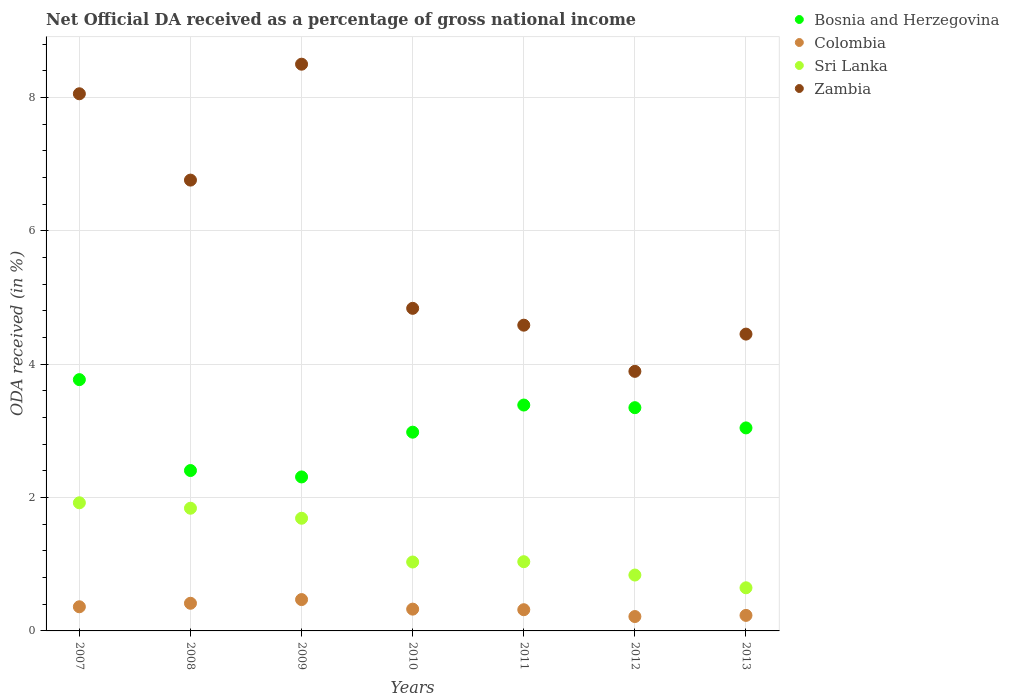How many different coloured dotlines are there?
Give a very brief answer. 4. What is the net official DA received in Sri Lanka in 2012?
Make the answer very short. 0.84. Across all years, what is the maximum net official DA received in Bosnia and Herzegovina?
Give a very brief answer. 3.77. Across all years, what is the minimum net official DA received in Sri Lanka?
Keep it short and to the point. 0.65. In which year was the net official DA received in Colombia maximum?
Offer a terse response. 2009. What is the total net official DA received in Zambia in the graph?
Make the answer very short. 41.08. What is the difference between the net official DA received in Colombia in 2010 and that in 2011?
Your answer should be compact. 0.01. What is the difference between the net official DA received in Sri Lanka in 2013 and the net official DA received in Colombia in 2010?
Provide a succinct answer. 0.32. What is the average net official DA received in Colombia per year?
Offer a very short reply. 0.33. In the year 2011, what is the difference between the net official DA received in Bosnia and Herzegovina and net official DA received in Zambia?
Your answer should be very brief. -1.2. What is the ratio of the net official DA received in Zambia in 2008 to that in 2010?
Provide a succinct answer. 1.4. Is the difference between the net official DA received in Bosnia and Herzegovina in 2007 and 2013 greater than the difference between the net official DA received in Zambia in 2007 and 2013?
Your answer should be compact. No. What is the difference between the highest and the second highest net official DA received in Colombia?
Your response must be concise. 0.06. What is the difference between the highest and the lowest net official DA received in Zambia?
Keep it short and to the point. 4.61. In how many years, is the net official DA received in Zambia greater than the average net official DA received in Zambia taken over all years?
Offer a very short reply. 3. Is the sum of the net official DA received in Zambia in 2007 and 2012 greater than the maximum net official DA received in Colombia across all years?
Your response must be concise. Yes. Is it the case that in every year, the sum of the net official DA received in Sri Lanka and net official DA received in Zambia  is greater than the net official DA received in Colombia?
Make the answer very short. Yes. Does the net official DA received in Colombia monotonically increase over the years?
Offer a terse response. No. Is the net official DA received in Zambia strictly less than the net official DA received in Sri Lanka over the years?
Keep it short and to the point. No. How many dotlines are there?
Offer a very short reply. 4. How many legend labels are there?
Ensure brevity in your answer.  4. How are the legend labels stacked?
Your response must be concise. Vertical. What is the title of the graph?
Ensure brevity in your answer.  Net Official DA received as a percentage of gross national income. What is the label or title of the X-axis?
Offer a terse response. Years. What is the label or title of the Y-axis?
Keep it short and to the point. ODA received (in %). What is the ODA received (in %) of Bosnia and Herzegovina in 2007?
Give a very brief answer. 3.77. What is the ODA received (in %) in Colombia in 2007?
Your answer should be compact. 0.36. What is the ODA received (in %) in Sri Lanka in 2007?
Provide a short and direct response. 1.92. What is the ODA received (in %) of Zambia in 2007?
Make the answer very short. 8.05. What is the ODA received (in %) in Bosnia and Herzegovina in 2008?
Provide a short and direct response. 2.41. What is the ODA received (in %) in Colombia in 2008?
Your answer should be very brief. 0.41. What is the ODA received (in %) in Sri Lanka in 2008?
Offer a terse response. 1.84. What is the ODA received (in %) of Zambia in 2008?
Give a very brief answer. 6.76. What is the ODA received (in %) of Bosnia and Herzegovina in 2009?
Keep it short and to the point. 2.31. What is the ODA received (in %) in Colombia in 2009?
Make the answer very short. 0.47. What is the ODA received (in %) in Sri Lanka in 2009?
Provide a succinct answer. 1.69. What is the ODA received (in %) of Zambia in 2009?
Offer a very short reply. 8.5. What is the ODA received (in %) of Bosnia and Herzegovina in 2010?
Ensure brevity in your answer.  2.98. What is the ODA received (in %) in Colombia in 2010?
Provide a short and direct response. 0.33. What is the ODA received (in %) of Sri Lanka in 2010?
Your answer should be compact. 1.03. What is the ODA received (in %) of Zambia in 2010?
Offer a very short reply. 4.84. What is the ODA received (in %) in Bosnia and Herzegovina in 2011?
Offer a terse response. 3.39. What is the ODA received (in %) of Colombia in 2011?
Ensure brevity in your answer.  0.32. What is the ODA received (in %) of Sri Lanka in 2011?
Your answer should be compact. 1.04. What is the ODA received (in %) of Zambia in 2011?
Your response must be concise. 4.58. What is the ODA received (in %) in Bosnia and Herzegovina in 2012?
Make the answer very short. 3.35. What is the ODA received (in %) of Colombia in 2012?
Your answer should be compact. 0.22. What is the ODA received (in %) of Sri Lanka in 2012?
Your response must be concise. 0.84. What is the ODA received (in %) of Zambia in 2012?
Ensure brevity in your answer.  3.89. What is the ODA received (in %) in Bosnia and Herzegovina in 2013?
Keep it short and to the point. 3.04. What is the ODA received (in %) of Colombia in 2013?
Your answer should be compact. 0.23. What is the ODA received (in %) in Sri Lanka in 2013?
Your answer should be compact. 0.65. What is the ODA received (in %) in Zambia in 2013?
Your answer should be very brief. 4.45. Across all years, what is the maximum ODA received (in %) of Bosnia and Herzegovina?
Your answer should be compact. 3.77. Across all years, what is the maximum ODA received (in %) of Colombia?
Ensure brevity in your answer.  0.47. Across all years, what is the maximum ODA received (in %) in Sri Lanka?
Your answer should be very brief. 1.92. Across all years, what is the maximum ODA received (in %) in Zambia?
Provide a short and direct response. 8.5. Across all years, what is the minimum ODA received (in %) in Bosnia and Herzegovina?
Keep it short and to the point. 2.31. Across all years, what is the minimum ODA received (in %) of Colombia?
Offer a very short reply. 0.22. Across all years, what is the minimum ODA received (in %) in Sri Lanka?
Your answer should be compact. 0.65. Across all years, what is the minimum ODA received (in %) of Zambia?
Provide a succinct answer. 3.89. What is the total ODA received (in %) of Bosnia and Herzegovina in the graph?
Offer a very short reply. 21.24. What is the total ODA received (in %) of Colombia in the graph?
Your answer should be very brief. 2.34. What is the total ODA received (in %) in Sri Lanka in the graph?
Your answer should be very brief. 9.01. What is the total ODA received (in %) in Zambia in the graph?
Your answer should be very brief. 41.08. What is the difference between the ODA received (in %) of Bosnia and Herzegovina in 2007 and that in 2008?
Offer a very short reply. 1.36. What is the difference between the ODA received (in %) of Colombia in 2007 and that in 2008?
Provide a succinct answer. -0.05. What is the difference between the ODA received (in %) in Sri Lanka in 2007 and that in 2008?
Offer a very short reply. 0.08. What is the difference between the ODA received (in %) in Zambia in 2007 and that in 2008?
Your response must be concise. 1.29. What is the difference between the ODA received (in %) in Bosnia and Herzegovina in 2007 and that in 2009?
Provide a short and direct response. 1.46. What is the difference between the ODA received (in %) of Colombia in 2007 and that in 2009?
Provide a short and direct response. -0.11. What is the difference between the ODA received (in %) in Sri Lanka in 2007 and that in 2009?
Offer a terse response. 0.23. What is the difference between the ODA received (in %) of Zambia in 2007 and that in 2009?
Your answer should be compact. -0.44. What is the difference between the ODA received (in %) in Bosnia and Herzegovina in 2007 and that in 2010?
Provide a succinct answer. 0.79. What is the difference between the ODA received (in %) in Colombia in 2007 and that in 2010?
Offer a very short reply. 0.04. What is the difference between the ODA received (in %) in Sri Lanka in 2007 and that in 2010?
Make the answer very short. 0.89. What is the difference between the ODA received (in %) in Zambia in 2007 and that in 2010?
Your answer should be compact. 3.22. What is the difference between the ODA received (in %) in Bosnia and Herzegovina in 2007 and that in 2011?
Make the answer very short. 0.38. What is the difference between the ODA received (in %) in Colombia in 2007 and that in 2011?
Provide a short and direct response. 0.04. What is the difference between the ODA received (in %) in Sri Lanka in 2007 and that in 2011?
Ensure brevity in your answer.  0.88. What is the difference between the ODA received (in %) in Zambia in 2007 and that in 2011?
Offer a very short reply. 3.47. What is the difference between the ODA received (in %) of Bosnia and Herzegovina in 2007 and that in 2012?
Provide a succinct answer. 0.42. What is the difference between the ODA received (in %) in Colombia in 2007 and that in 2012?
Offer a terse response. 0.15. What is the difference between the ODA received (in %) of Sri Lanka in 2007 and that in 2012?
Your answer should be very brief. 1.08. What is the difference between the ODA received (in %) in Zambia in 2007 and that in 2012?
Your answer should be compact. 4.16. What is the difference between the ODA received (in %) of Bosnia and Herzegovina in 2007 and that in 2013?
Ensure brevity in your answer.  0.72. What is the difference between the ODA received (in %) in Colombia in 2007 and that in 2013?
Provide a short and direct response. 0.13. What is the difference between the ODA received (in %) of Sri Lanka in 2007 and that in 2013?
Make the answer very short. 1.27. What is the difference between the ODA received (in %) in Zambia in 2007 and that in 2013?
Provide a succinct answer. 3.6. What is the difference between the ODA received (in %) of Bosnia and Herzegovina in 2008 and that in 2009?
Offer a very short reply. 0.1. What is the difference between the ODA received (in %) of Colombia in 2008 and that in 2009?
Give a very brief answer. -0.06. What is the difference between the ODA received (in %) of Sri Lanka in 2008 and that in 2009?
Offer a very short reply. 0.15. What is the difference between the ODA received (in %) of Zambia in 2008 and that in 2009?
Make the answer very short. -1.74. What is the difference between the ODA received (in %) of Bosnia and Herzegovina in 2008 and that in 2010?
Make the answer very short. -0.58. What is the difference between the ODA received (in %) of Colombia in 2008 and that in 2010?
Your answer should be very brief. 0.09. What is the difference between the ODA received (in %) in Sri Lanka in 2008 and that in 2010?
Offer a very short reply. 0.81. What is the difference between the ODA received (in %) of Zambia in 2008 and that in 2010?
Keep it short and to the point. 1.92. What is the difference between the ODA received (in %) of Bosnia and Herzegovina in 2008 and that in 2011?
Provide a short and direct response. -0.98. What is the difference between the ODA received (in %) in Colombia in 2008 and that in 2011?
Provide a short and direct response. 0.1. What is the difference between the ODA received (in %) in Sri Lanka in 2008 and that in 2011?
Keep it short and to the point. 0.8. What is the difference between the ODA received (in %) of Zambia in 2008 and that in 2011?
Your response must be concise. 2.18. What is the difference between the ODA received (in %) in Bosnia and Herzegovina in 2008 and that in 2012?
Provide a succinct answer. -0.94. What is the difference between the ODA received (in %) of Colombia in 2008 and that in 2012?
Give a very brief answer. 0.2. What is the difference between the ODA received (in %) of Sri Lanka in 2008 and that in 2012?
Keep it short and to the point. 1. What is the difference between the ODA received (in %) of Zambia in 2008 and that in 2012?
Keep it short and to the point. 2.87. What is the difference between the ODA received (in %) of Bosnia and Herzegovina in 2008 and that in 2013?
Your answer should be very brief. -0.64. What is the difference between the ODA received (in %) of Colombia in 2008 and that in 2013?
Offer a very short reply. 0.18. What is the difference between the ODA received (in %) of Sri Lanka in 2008 and that in 2013?
Make the answer very short. 1.19. What is the difference between the ODA received (in %) of Zambia in 2008 and that in 2013?
Offer a very short reply. 2.31. What is the difference between the ODA received (in %) in Bosnia and Herzegovina in 2009 and that in 2010?
Ensure brevity in your answer.  -0.67. What is the difference between the ODA received (in %) of Colombia in 2009 and that in 2010?
Your answer should be compact. 0.14. What is the difference between the ODA received (in %) of Sri Lanka in 2009 and that in 2010?
Offer a terse response. 0.66. What is the difference between the ODA received (in %) in Zambia in 2009 and that in 2010?
Your answer should be compact. 3.66. What is the difference between the ODA received (in %) of Bosnia and Herzegovina in 2009 and that in 2011?
Offer a terse response. -1.08. What is the difference between the ODA received (in %) of Colombia in 2009 and that in 2011?
Your answer should be very brief. 0.15. What is the difference between the ODA received (in %) in Sri Lanka in 2009 and that in 2011?
Offer a terse response. 0.65. What is the difference between the ODA received (in %) of Zambia in 2009 and that in 2011?
Offer a terse response. 3.91. What is the difference between the ODA received (in %) in Bosnia and Herzegovina in 2009 and that in 2012?
Ensure brevity in your answer.  -1.04. What is the difference between the ODA received (in %) of Colombia in 2009 and that in 2012?
Your answer should be compact. 0.25. What is the difference between the ODA received (in %) of Sri Lanka in 2009 and that in 2012?
Ensure brevity in your answer.  0.85. What is the difference between the ODA received (in %) in Zambia in 2009 and that in 2012?
Ensure brevity in your answer.  4.61. What is the difference between the ODA received (in %) in Bosnia and Herzegovina in 2009 and that in 2013?
Provide a short and direct response. -0.74. What is the difference between the ODA received (in %) in Colombia in 2009 and that in 2013?
Offer a terse response. 0.24. What is the difference between the ODA received (in %) of Sri Lanka in 2009 and that in 2013?
Ensure brevity in your answer.  1.04. What is the difference between the ODA received (in %) of Zambia in 2009 and that in 2013?
Your answer should be compact. 4.05. What is the difference between the ODA received (in %) of Bosnia and Herzegovina in 2010 and that in 2011?
Provide a succinct answer. -0.41. What is the difference between the ODA received (in %) of Colombia in 2010 and that in 2011?
Provide a short and direct response. 0.01. What is the difference between the ODA received (in %) in Sri Lanka in 2010 and that in 2011?
Your answer should be compact. -0. What is the difference between the ODA received (in %) of Zambia in 2010 and that in 2011?
Ensure brevity in your answer.  0.25. What is the difference between the ODA received (in %) of Bosnia and Herzegovina in 2010 and that in 2012?
Your response must be concise. -0.37. What is the difference between the ODA received (in %) in Colombia in 2010 and that in 2012?
Your response must be concise. 0.11. What is the difference between the ODA received (in %) in Sri Lanka in 2010 and that in 2012?
Ensure brevity in your answer.  0.2. What is the difference between the ODA received (in %) in Zambia in 2010 and that in 2012?
Your answer should be compact. 0.94. What is the difference between the ODA received (in %) in Bosnia and Herzegovina in 2010 and that in 2013?
Ensure brevity in your answer.  -0.06. What is the difference between the ODA received (in %) in Colombia in 2010 and that in 2013?
Ensure brevity in your answer.  0.09. What is the difference between the ODA received (in %) of Sri Lanka in 2010 and that in 2013?
Ensure brevity in your answer.  0.39. What is the difference between the ODA received (in %) of Zambia in 2010 and that in 2013?
Keep it short and to the point. 0.39. What is the difference between the ODA received (in %) of Bosnia and Herzegovina in 2011 and that in 2012?
Make the answer very short. 0.04. What is the difference between the ODA received (in %) in Colombia in 2011 and that in 2012?
Provide a succinct answer. 0.1. What is the difference between the ODA received (in %) of Sri Lanka in 2011 and that in 2012?
Make the answer very short. 0.2. What is the difference between the ODA received (in %) in Zambia in 2011 and that in 2012?
Your answer should be compact. 0.69. What is the difference between the ODA received (in %) of Bosnia and Herzegovina in 2011 and that in 2013?
Offer a terse response. 0.34. What is the difference between the ODA received (in %) of Colombia in 2011 and that in 2013?
Offer a very short reply. 0.09. What is the difference between the ODA received (in %) of Sri Lanka in 2011 and that in 2013?
Offer a very short reply. 0.39. What is the difference between the ODA received (in %) in Zambia in 2011 and that in 2013?
Keep it short and to the point. 0.13. What is the difference between the ODA received (in %) of Bosnia and Herzegovina in 2012 and that in 2013?
Keep it short and to the point. 0.3. What is the difference between the ODA received (in %) of Colombia in 2012 and that in 2013?
Your answer should be compact. -0.02. What is the difference between the ODA received (in %) in Sri Lanka in 2012 and that in 2013?
Make the answer very short. 0.19. What is the difference between the ODA received (in %) of Zambia in 2012 and that in 2013?
Your response must be concise. -0.56. What is the difference between the ODA received (in %) of Bosnia and Herzegovina in 2007 and the ODA received (in %) of Colombia in 2008?
Your answer should be compact. 3.35. What is the difference between the ODA received (in %) in Bosnia and Herzegovina in 2007 and the ODA received (in %) in Sri Lanka in 2008?
Provide a succinct answer. 1.93. What is the difference between the ODA received (in %) of Bosnia and Herzegovina in 2007 and the ODA received (in %) of Zambia in 2008?
Provide a short and direct response. -2.99. What is the difference between the ODA received (in %) in Colombia in 2007 and the ODA received (in %) in Sri Lanka in 2008?
Your answer should be very brief. -1.48. What is the difference between the ODA received (in %) in Colombia in 2007 and the ODA received (in %) in Zambia in 2008?
Your answer should be very brief. -6.4. What is the difference between the ODA received (in %) of Sri Lanka in 2007 and the ODA received (in %) of Zambia in 2008?
Make the answer very short. -4.84. What is the difference between the ODA received (in %) of Bosnia and Herzegovina in 2007 and the ODA received (in %) of Colombia in 2009?
Your response must be concise. 3.3. What is the difference between the ODA received (in %) in Bosnia and Herzegovina in 2007 and the ODA received (in %) in Sri Lanka in 2009?
Keep it short and to the point. 2.08. What is the difference between the ODA received (in %) of Bosnia and Herzegovina in 2007 and the ODA received (in %) of Zambia in 2009?
Make the answer very short. -4.73. What is the difference between the ODA received (in %) of Colombia in 2007 and the ODA received (in %) of Sri Lanka in 2009?
Provide a succinct answer. -1.33. What is the difference between the ODA received (in %) in Colombia in 2007 and the ODA received (in %) in Zambia in 2009?
Offer a very short reply. -8.14. What is the difference between the ODA received (in %) of Sri Lanka in 2007 and the ODA received (in %) of Zambia in 2009?
Provide a short and direct response. -6.58. What is the difference between the ODA received (in %) of Bosnia and Herzegovina in 2007 and the ODA received (in %) of Colombia in 2010?
Offer a terse response. 3.44. What is the difference between the ODA received (in %) in Bosnia and Herzegovina in 2007 and the ODA received (in %) in Sri Lanka in 2010?
Give a very brief answer. 2.73. What is the difference between the ODA received (in %) in Bosnia and Herzegovina in 2007 and the ODA received (in %) in Zambia in 2010?
Provide a succinct answer. -1.07. What is the difference between the ODA received (in %) in Colombia in 2007 and the ODA received (in %) in Sri Lanka in 2010?
Give a very brief answer. -0.67. What is the difference between the ODA received (in %) in Colombia in 2007 and the ODA received (in %) in Zambia in 2010?
Ensure brevity in your answer.  -4.48. What is the difference between the ODA received (in %) of Sri Lanka in 2007 and the ODA received (in %) of Zambia in 2010?
Keep it short and to the point. -2.92. What is the difference between the ODA received (in %) of Bosnia and Herzegovina in 2007 and the ODA received (in %) of Colombia in 2011?
Make the answer very short. 3.45. What is the difference between the ODA received (in %) in Bosnia and Herzegovina in 2007 and the ODA received (in %) in Sri Lanka in 2011?
Provide a succinct answer. 2.73. What is the difference between the ODA received (in %) of Bosnia and Herzegovina in 2007 and the ODA received (in %) of Zambia in 2011?
Ensure brevity in your answer.  -0.82. What is the difference between the ODA received (in %) of Colombia in 2007 and the ODA received (in %) of Sri Lanka in 2011?
Provide a short and direct response. -0.68. What is the difference between the ODA received (in %) in Colombia in 2007 and the ODA received (in %) in Zambia in 2011?
Your answer should be compact. -4.22. What is the difference between the ODA received (in %) in Sri Lanka in 2007 and the ODA received (in %) in Zambia in 2011?
Keep it short and to the point. -2.66. What is the difference between the ODA received (in %) of Bosnia and Herzegovina in 2007 and the ODA received (in %) of Colombia in 2012?
Keep it short and to the point. 3.55. What is the difference between the ODA received (in %) in Bosnia and Herzegovina in 2007 and the ODA received (in %) in Sri Lanka in 2012?
Your answer should be compact. 2.93. What is the difference between the ODA received (in %) in Bosnia and Herzegovina in 2007 and the ODA received (in %) in Zambia in 2012?
Provide a succinct answer. -0.12. What is the difference between the ODA received (in %) of Colombia in 2007 and the ODA received (in %) of Sri Lanka in 2012?
Provide a succinct answer. -0.48. What is the difference between the ODA received (in %) of Colombia in 2007 and the ODA received (in %) of Zambia in 2012?
Give a very brief answer. -3.53. What is the difference between the ODA received (in %) of Sri Lanka in 2007 and the ODA received (in %) of Zambia in 2012?
Your answer should be very brief. -1.97. What is the difference between the ODA received (in %) in Bosnia and Herzegovina in 2007 and the ODA received (in %) in Colombia in 2013?
Your answer should be very brief. 3.54. What is the difference between the ODA received (in %) in Bosnia and Herzegovina in 2007 and the ODA received (in %) in Sri Lanka in 2013?
Provide a succinct answer. 3.12. What is the difference between the ODA received (in %) in Bosnia and Herzegovina in 2007 and the ODA received (in %) in Zambia in 2013?
Make the answer very short. -0.68. What is the difference between the ODA received (in %) in Colombia in 2007 and the ODA received (in %) in Sri Lanka in 2013?
Offer a very short reply. -0.28. What is the difference between the ODA received (in %) of Colombia in 2007 and the ODA received (in %) of Zambia in 2013?
Keep it short and to the point. -4.09. What is the difference between the ODA received (in %) of Sri Lanka in 2007 and the ODA received (in %) of Zambia in 2013?
Make the answer very short. -2.53. What is the difference between the ODA received (in %) in Bosnia and Herzegovina in 2008 and the ODA received (in %) in Colombia in 2009?
Make the answer very short. 1.94. What is the difference between the ODA received (in %) in Bosnia and Herzegovina in 2008 and the ODA received (in %) in Sri Lanka in 2009?
Keep it short and to the point. 0.72. What is the difference between the ODA received (in %) of Bosnia and Herzegovina in 2008 and the ODA received (in %) of Zambia in 2009?
Your answer should be compact. -6.09. What is the difference between the ODA received (in %) in Colombia in 2008 and the ODA received (in %) in Sri Lanka in 2009?
Your answer should be compact. -1.27. What is the difference between the ODA received (in %) in Colombia in 2008 and the ODA received (in %) in Zambia in 2009?
Ensure brevity in your answer.  -8.08. What is the difference between the ODA received (in %) of Sri Lanka in 2008 and the ODA received (in %) of Zambia in 2009?
Your answer should be very brief. -6.66. What is the difference between the ODA received (in %) in Bosnia and Herzegovina in 2008 and the ODA received (in %) in Colombia in 2010?
Make the answer very short. 2.08. What is the difference between the ODA received (in %) of Bosnia and Herzegovina in 2008 and the ODA received (in %) of Sri Lanka in 2010?
Your answer should be very brief. 1.37. What is the difference between the ODA received (in %) in Bosnia and Herzegovina in 2008 and the ODA received (in %) in Zambia in 2010?
Provide a succinct answer. -2.43. What is the difference between the ODA received (in %) of Colombia in 2008 and the ODA received (in %) of Sri Lanka in 2010?
Make the answer very short. -0.62. What is the difference between the ODA received (in %) of Colombia in 2008 and the ODA received (in %) of Zambia in 2010?
Offer a very short reply. -4.42. What is the difference between the ODA received (in %) in Sri Lanka in 2008 and the ODA received (in %) in Zambia in 2010?
Your answer should be very brief. -3. What is the difference between the ODA received (in %) in Bosnia and Herzegovina in 2008 and the ODA received (in %) in Colombia in 2011?
Make the answer very short. 2.09. What is the difference between the ODA received (in %) in Bosnia and Herzegovina in 2008 and the ODA received (in %) in Sri Lanka in 2011?
Ensure brevity in your answer.  1.37. What is the difference between the ODA received (in %) of Bosnia and Herzegovina in 2008 and the ODA received (in %) of Zambia in 2011?
Your answer should be very brief. -2.18. What is the difference between the ODA received (in %) in Colombia in 2008 and the ODA received (in %) in Sri Lanka in 2011?
Give a very brief answer. -0.62. What is the difference between the ODA received (in %) of Colombia in 2008 and the ODA received (in %) of Zambia in 2011?
Offer a very short reply. -4.17. What is the difference between the ODA received (in %) of Sri Lanka in 2008 and the ODA received (in %) of Zambia in 2011?
Provide a short and direct response. -2.74. What is the difference between the ODA received (in %) of Bosnia and Herzegovina in 2008 and the ODA received (in %) of Colombia in 2012?
Your response must be concise. 2.19. What is the difference between the ODA received (in %) in Bosnia and Herzegovina in 2008 and the ODA received (in %) in Sri Lanka in 2012?
Your answer should be compact. 1.57. What is the difference between the ODA received (in %) in Bosnia and Herzegovina in 2008 and the ODA received (in %) in Zambia in 2012?
Offer a very short reply. -1.49. What is the difference between the ODA received (in %) of Colombia in 2008 and the ODA received (in %) of Sri Lanka in 2012?
Your answer should be compact. -0.42. What is the difference between the ODA received (in %) of Colombia in 2008 and the ODA received (in %) of Zambia in 2012?
Provide a succinct answer. -3.48. What is the difference between the ODA received (in %) of Sri Lanka in 2008 and the ODA received (in %) of Zambia in 2012?
Your answer should be compact. -2.05. What is the difference between the ODA received (in %) in Bosnia and Herzegovina in 2008 and the ODA received (in %) in Colombia in 2013?
Provide a short and direct response. 2.17. What is the difference between the ODA received (in %) of Bosnia and Herzegovina in 2008 and the ODA received (in %) of Sri Lanka in 2013?
Your response must be concise. 1.76. What is the difference between the ODA received (in %) in Bosnia and Herzegovina in 2008 and the ODA received (in %) in Zambia in 2013?
Give a very brief answer. -2.05. What is the difference between the ODA received (in %) in Colombia in 2008 and the ODA received (in %) in Sri Lanka in 2013?
Offer a terse response. -0.23. What is the difference between the ODA received (in %) in Colombia in 2008 and the ODA received (in %) in Zambia in 2013?
Offer a terse response. -4.04. What is the difference between the ODA received (in %) in Sri Lanka in 2008 and the ODA received (in %) in Zambia in 2013?
Make the answer very short. -2.61. What is the difference between the ODA received (in %) in Bosnia and Herzegovina in 2009 and the ODA received (in %) in Colombia in 2010?
Your response must be concise. 1.98. What is the difference between the ODA received (in %) of Bosnia and Herzegovina in 2009 and the ODA received (in %) of Sri Lanka in 2010?
Make the answer very short. 1.28. What is the difference between the ODA received (in %) in Bosnia and Herzegovina in 2009 and the ODA received (in %) in Zambia in 2010?
Your answer should be very brief. -2.53. What is the difference between the ODA received (in %) of Colombia in 2009 and the ODA received (in %) of Sri Lanka in 2010?
Make the answer very short. -0.56. What is the difference between the ODA received (in %) in Colombia in 2009 and the ODA received (in %) in Zambia in 2010?
Ensure brevity in your answer.  -4.37. What is the difference between the ODA received (in %) in Sri Lanka in 2009 and the ODA received (in %) in Zambia in 2010?
Ensure brevity in your answer.  -3.15. What is the difference between the ODA received (in %) in Bosnia and Herzegovina in 2009 and the ODA received (in %) in Colombia in 2011?
Offer a terse response. 1.99. What is the difference between the ODA received (in %) of Bosnia and Herzegovina in 2009 and the ODA received (in %) of Sri Lanka in 2011?
Your response must be concise. 1.27. What is the difference between the ODA received (in %) of Bosnia and Herzegovina in 2009 and the ODA received (in %) of Zambia in 2011?
Ensure brevity in your answer.  -2.28. What is the difference between the ODA received (in %) of Colombia in 2009 and the ODA received (in %) of Sri Lanka in 2011?
Make the answer very short. -0.57. What is the difference between the ODA received (in %) of Colombia in 2009 and the ODA received (in %) of Zambia in 2011?
Make the answer very short. -4.11. What is the difference between the ODA received (in %) in Sri Lanka in 2009 and the ODA received (in %) in Zambia in 2011?
Keep it short and to the point. -2.9. What is the difference between the ODA received (in %) of Bosnia and Herzegovina in 2009 and the ODA received (in %) of Colombia in 2012?
Your answer should be compact. 2.09. What is the difference between the ODA received (in %) in Bosnia and Herzegovina in 2009 and the ODA received (in %) in Sri Lanka in 2012?
Your response must be concise. 1.47. What is the difference between the ODA received (in %) in Bosnia and Herzegovina in 2009 and the ODA received (in %) in Zambia in 2012?
Give a very brief answer. -1.58. What is the difference between the ODA received (in %) in Colombia in 2009 and the ODA received (in %) in Sri Lanka in 2012?
Your response must be concise. -0.37. What is the difference between the ODA received (in %) in Colombia in 2009 and the ODA received (in %) in Zambia in 2012?
Keep it short and to the point. -3.42. What is the difference between the ODA received (in %) in Sri Lanka in 2009 and the ODA received (in %) in Zambia in 2012?
Provide a succinct answer. -2.2. What is the difference between the ODA received (in %) of Bosnia and Herzegovina in 2009 and the ODA received (in %) of Colombia in 2013?
Make the answer very short. 2.08. What is the difference between the ODA received (in %) in Bosnia and Herzegovina in 2009 and the ODA received (in %) in Sri Lanka in 2013?
Make the answer very short. 1.66. What is the difference between the ODA received (in %) of Bosnia and Herzegovina in 2009 and the ODA received (in %) of Zambia in 2013?
Offer a terse response. -2.14. What is the difference between the ODA received (in %) in Colombia in 2009 and the ODA received (in %) in Sri Lanka in 2013?
Your answer should be compact. -0.18. What is the difference between the ODA received (in %) in Colombia in 2009 and the ODA received (in %) in Zambia in 2013?
Provide a short and direct response. -3.98. What is the difference between the ODA received (in %) of Sri Lanka in 2009 and the ODA received (in %) of Zambia in 2013?
Keep it short and to the point. -2.76. What is the difference between the ODA received (in %) in Bosnia and Herzegovina in 2010 and the ODA received (in %) in Colombia in 2011?
Your answer should be compact. 2.66. What is the difference between the ODA received (in %) in Bosnia and Herzegovina in 2010 and the ODA received (in %) in Sri Lanka in 2011?
Your answer should be very brief. 1.94. What is the difference between the ODA received (in %) of Bosnia and Herzegovina in 2010 and the ODA received (in %) of Zambia in 2011?
Provide a succinct answer. -1.6. What is the difference between the ODA received (in %) of Colombia in 2010 and the ODA received (in %) of Sri Lanka in 2011?
Your answer should be very brief. -0.71. What is the difference between the ODA received (in %) of Colombia in 2010 and the ODA received (in %) of Zambia in 2011?
Provide a short and direct response. -4.26. What is the difference between the ODA received (in %) in Sri Lanka in 2010 and the ODA received (in %) in Zambia in 2011?
Your answer should be compact. -3.55. What is the difference between the ODA received (in %) of Bosnia and Herzegovina in 2010 and the ODA received (in %) of Colombia in 2012?
Offer a very short reply. 2.76. What is the difference between the ODA received (in %) of Bosnia and Herzegovina in 2010 and the ODA received (in %) of Sri Lanka in 2012?
Provide a short and direct response. 2.14. What is the difference between the ODA received (in %) of Bosnia and Herzegovina in 2010 and the ODA received (in %) of Zambia in 2012?
Your response must be concise. -0.91. What is the difference between the ODA received (in %) of Colombia in 2010 and the ODA received (in %) of Sri Lanka in 2012?
Give a very brief answer. -0.51. What is the difference between the ODA received (in %) of Colombia in 2010 and the ODA received (in %) of Zambia in 2012?
Ensure brevity in your answer.  -3.57. What is the difference between the ODA received (in %) of Sri Lanka in 2010 and the ODA received (in %) of Zambia in 2012?
Offer a terse response. -2.86. What is the difference between the ODA received (in %) in Bosnia and Herzegovina in 2010 and the ODA received (in %) in Colombia in 2013?
Keep it short and to the point. 2.75. What is the difference between the ODA received (in %) in Bosnia and Herzegovina in 2010 and the ODA received (in %) in Sri Lanka in 2013?
Offer a terse response. 2.33. What is the difference between the ODA received (in %) in Bosnia and Herzegovina in 2010 and the ODA received (in %) in Zambia in 2013?
Provide a short and direct response. -1.47. What is the difference between the ODA received (in %) in Colombia in 2010 and the ODA received (in %) in Sri Lanka in 2013?
Your answer should be compact. -0.32. What is the difference between the ODA received (in %) of Colombia in 2010 and the ODA received (in %) of Zambia in 2013?
Ensure brevity in your answer.  -4.12. What is the difference between the ODA received (in %) in Sri Lanka in 2010 and the ODA received (in %) in Zambia in 2013?
Offer a terse response. -3.42. What is the difference between the ODA received (in %) of Bosnia and Herzegovina in 2011 and the ODA received (in %) of Colombia in 2012?
Provide a succinct answer. 3.17. What is the difference between the ODA received (in %) in Bosnia and Herzegovina in 2011 and the ODA received (in %) in Sri Lanka in 2012?
Provide a succinct answer. 2.55. What is the difference between the ODA received (in %) in Bosnia and Herzegovina in 2011 and the ODA received (in %) in Zambia in 2012?
Provide a succinct answer. -0.51. What is the difference between the ODA received (in %) of Colombia in 2011 and the ODA received (in %) of Sri Lanka in 2012?
Give a very brief answer. -0.52. What is the difference between the ODA received (in %) of Colombia in 2011 and the ODA received (in %) of Zambia in 2012?
Your answer should be compact. -3.57. What is the difference between the ODA received (in %) in Sri Lanka in 2011 and the ODA received (in %) in Zambia in 2012?
Give a very brief answer. -2.85. What is the difference between the ODA received (in %) of Bosnia and Herzegovina in 2011 and the ODA received (in %) of Colombia in 2013?
Make the answer very short. 3.15. What is the difference between the ODA received (in %) of Bosnia and Herzegovina in 2011 and the ODA received (in %) of Sri Lanka in 2013?
Keep it short and to the point. 2.74. What is the difference between the ODA received (in %) of Bosnia and Herzegovina in 2011 and the ODA received (in %) of Zambia in 2013?
Provide a succinct answer. -1.06. What is the difference between the ODA received (in %) in Colombia in 2011 and the ODA received (in %) in Sri Lanka in 2013?
Your answer should be very brief. -0.33. What is the difference between the ODA received (in %) of Colombia in 2011 and the ODA received (in %) of Zambia in 2013?
Offer a terse response. -4.13. What is the difference between the ODA received (in %) of Sri Lanka in 2011 and the ODA received (in %) of Zambia in 2013?
Give a very brief answer. -3.41. What is the difference between the ODA received (in %) in Bosnia and Herzegovina in 2012 and the ODA received (in %) in Colombia in 2013?
Keep it short and to the point. 3.11. What is the difference between the ODA received (in %) in Bosnia and Herzegovina in 2012 and the ODA received (in %) in Sri Lanka in 2013?
Give a very brief answer. 2.7. What is the difference between the ODA received (in %) in Bosnia and Herzegovina in 2012 and the ODA received (in %) in Zambia in 2013?
Your answer should be very brief. -1.1. What is the difference between the ODA received (in %) in Colombia in 2012 and the ODA received (in %) in Sri Lanka in 2013?
Provide a short and direct response. -0.43. What is the difference between the ODA received (in %) of Colombia in 2012 and the ODA received (in %) of Zambia in 2013?
Provide a short and direct response. -4.24. What is the difference between the ODA received (in %) of Sri Lanka in 2012 and the ODA received (in %) of Zambia in 2013?
Your answer should be compact. -3.61. What is the average ODA received (in %) of Bosnia and Herzegovina per year?
Your answer should be very brief. 3.03. What is the average ODA received (in %) in Colombia per year?
Your answer should be very brief. 0.33. What is the average ODA received (in %) of Sri Lanka per year?
Ensure brevity in your answer.  1.29. What is the average ODA received (in %) of Zambia per year?
Offer a terse response. 5.87. In the year 2007, what is the difference between the ODA received (in %) in Bosnia and Herzegovina and ODA received (in %) in Colombia?
Your answer should be compact. 3.41. In the year 2007, what is the difference between the ODA received (in %) of Bosnia and Herzegovina and ODA received (in %) of Sri Lanka?
Ensure brevity in your answer.  1.85. In the year 2007, what is the difference between the ODA received (in %) in Bosnia and Herzegovina and ODA received (in %) in Zambia?
Your answer should be very brief. -4.29. In the year 2007, what is the difference between the ODA received (in %) of Colombia and ODA received (in %) of Sri Lanka?
Keep it short and to the point. -1.56. In the year 2007, what is the difference between the ODA received (in %) of Colombia and ODA received (in %) of Zambia?
Provide a succinct answer. -7.69. In the year 2007, what is the difference between the ODA received (in %) in Sri Lanka and ODA received (in %) in Zambia?
Your response must be concise. -6.13. In the year 2008, what is the difference between the ODA received (in %) of Bosnia and Herzegovina and ODA received (in %) of Colombia?
Keep it short and to the point. 1.99. In the year 2008, what is the difference between the ODA received (in %) in Bosnia and Herzegovina and ODA received (in %) in Sri Lanka?
Ensure brevity in your answer.  0.57. In the year 2008, what is the difference between the ODA received (in %) in Bosnia and Herzegovina and ODA received (in %) in Zambia?
Give a very brief answer. -4.36. In the year 2008, what is the difference between the ODA received (in %) of Colombia and ODA received (in %) of Sri Lanka?
Provide a succinct answer. -1.43. In the year 2008, what is the difference between the ODA received (in %) in Colombia and ODA received (in %) in Zambia?
Provide a succinct answer. -6.35. In the year 2008, what is the difference between the ODA received (in %) of Sri Lanka and ODA received (in %) of Zambia?
Offer a terse response. -4.92. In the year 2009, what is the difference between the ODA received (in %) in Bosnia and Herzegovina and ODA received (in %) in Colombia?
Keep it short and to the point. 1.84. In the year 2009, what is the difference between the ODA received (in %) of Bosnia and Herzegovina and ODA received (in %) of Sri Lanka?
Your answer should be very brief. 0.62. In the year 2009, what is the difference between the ODA received (in %) of Bosnia and Herzegovina and ODA received (in %) of Zambia?
Your response must be concise. -6.19. In the year 2009, what is the difference between the ODA received (in %) of Colombia and ODA received (in %) of Sri Lanka?
Offer a terse response. -1.22. In the year 2009, what is the difference between the ODA received (in %) of Colombia and ODA received (in %) of Zambia?
Your response must be concise. -8.03. In the year 2009, what is the difference between the ODA received (in %) in Sri Lanka and ODA received (in %) in Zambia?
Your answer should be compact. -6.81. In the year 2010, what is the difference between the ODA received (in %) of Bosnia and Herzegovina and ODA received (in %) of Colombia?
Provide a short and direct response. 2.65. In the year 2010, what is the difference between the ODA received (in %) in Bosnia and Herzegovina and ODA received (in %) in Sri Lanka?
Ensure brevity in your answer.  1.95. In the year 2010, what is the difference between the ODA received (in %) in Bosnia and Herzegovina and ODA received (in %) in Zambia?
Keep it short and to the point. -1.86. In the year 2010, what is the difference between the ODA received (in %) in Colombia and ODA received (in %) in Sri Lanka?
Offer a terse response. -0.71. In the year 2010, what is the difference between the ODA received (in %) in Colombia and ODA received (in %) in Zambia?
Your answer should be very brief. -4.51. In the year 2010, what is the difference between the ODA received (in %) in Sri Lanka and ODA received (in %) in Zambia?
Provide a short and direct response. -3.8. In the year 2011, what is the difference between the ODA received (in %) of Bosnia and Herzegovina and ODA received (in %) of Colombia?
Your answer should be compact. 3.07. In the year 2011, what is the difference between the ODA received (in %) of Bosnia and Herzegovina and ODA received (in %) of Sri Lanka?
Offer a terse response. 2.35. In the year 2011, what is the difference between the ODA received (in %) in Bosnia and Herzegovina and ODA received (in %) in Zambia?
Your response must be concise. -1.2. In the year 2011, what is the difference between the ODA received (in %) of Colombia and ODA received (in %) of Sri Lanka?
Your response must be concise. -0.72. In the year 2011, what is the difference between the ODA received (in %) in Colombia and ODA received (in %) in Zambia?
Offer a very short reply. -4.27. In the year 2011, what is the difference between the ODA received (in %) in Sri Lanka and ODA received (in %) in Zambia?
Make the answer very short. -3.55. In the year 2012, what is the difference between the ODA received (in %) of Bosnia and Herzegovina and ODA received (in %) of Colombia?
Your response must be concise. 3.13. In the year 2012, what is the difference between the ODA received (in %) in Bosnia and Herzegovina and ODA received (in %) in Sri Lanka?
Make the answer very short. 2.51. In the year 2012, what is the difference between the ODA received (in %) in Bosnia and Herzegovina and ODA received (in %) in Zambia?
Offer a terse response. -0.54. In the year 2012, what is the difference between the ODA received (in %) of Colombia and ODA received (in %) of Sri Lanka?
Provide a succinct answer. -0.62. In the year 2012, what is the difference between the ODA received (in %) in Colombia and ODA received (in %) in Zambia?
Your response must be concise. -3.68. In the year 2012, what is the difference between the ODA received (in %) in Sri Lanka and ODA received (in %) in Zambia?
Your response must be concise. -3.05. In the year 2013, what is the difference between the ODA received (in %) of Bosnia and Herzegovina and ODA received (in %) of Colombia?
Give a very brief answer. 2.81. In the year 2013, what is the difference between the ODA received (in %) of Bosnia and Herzegovina and ODA received (in %) of Sri Lanka?
Give a very brief answer. 2.4. In the year 2013, what is the difference between the ODA received (in %) of Bosnia and Herzegovina and ODA received (in %) of Zambia?
Ensure brevity in your answer.  -1.41. In the year 2013, what is the difference between the ODA received (in %) in Colombia and ODA received (in %) in Sri Lanka?
Provide a succinct answer. -0.41. In the year 2013, what is the difference between the ODA received (in %) of Colombia and ODA received (in %) of Zambia?
Offer a terse response. -4.22. In the year 2013, what is the difference between the ODA received (in %) of Sri Lanka and ODA received (in %) of Zambia?
Your answer should be compact. -3.8. What is the ratio of the ODA received (in %) of Bosnia and Herzegovina in 2007 to that in 2008?
Ensure brevity in your answer.  1.57. What is the ratio of the ODA received (in %) of Colombia in 2007 to that in 2008?
Give a very brief answer. 0.87. What is the ratio of the ODA received (in %) of Sri Lanka in 2007 to that in 2008?
Your answer should be compact. 1.04. What is the ratio of the ODA received (in %) in Zambia in 2007 to that in 2008?
Offer a very short reply. 1.19. What is the ratio of the ODA received (in %) of Bosnia and Herzegovina in 2007 to that in 2009?
Offer a very short reply. 1.63. What is the ratio of the ODA received (in %) of Colombia in 2007 to that in 2009?
Keep it short and to the point. 0.77. What is the ratio of the ODA received (in %) in Sri Lanka in 2007 to that in 2009?
Provide a succinct answer. 1.14. What is the ratio of the ODA received (in %) of Zambia in 2007 to that in 2009?
Make the answer very short. 0.95. What is the ratio of the ODA received (in %) of Bosnia and Herzegovina in 2007 to that in 2010?
Provide a succinct answer. 1.26. What is the ratio of the ODA received (in %) of Colombia in 2007 to that in 2010?
Keep it short and to the point. 1.11. What is the ratio of the ODA received (in %) of Sri Lanka in 2007 to that in 2010?
Keep it short and to the point. 1.86. What is the ratio of the ODA received (in %) in Zambia in 2007 to that in 2010?
Your answer should be very brief. 1.67. What is the ratio of the ODA received (in %) in Bosnia and Herzegovina in 2007 to that in 2011?
Ensure brevity in your answer.  1.11. What is the ratio of the ODA received (in %) in Colombia in 2007 to that in 2011?
Your response must be concise. 1.14. What is the ratio of the ODA received (in %) in Sri Lanka in 2007 to that in 2011?
Your answer should be very brief. 1.85. What is the ratio of the ODA received (in %) of Zambia in 2007 to that in 2011?
Your answer should be compact. 1.76. What is the ratio of the ODA received (in %) in Bosnia and Herzegovina in 2007 to that in 2012?
Provide a short and direct response. 1.13. What is the ratio of the ODA received (in %) of Colombia in 2007 to that in 2012?
Your response must be concise. 1.68. What is the ratio of the ODA received (in %) of Sri Lanka in 2007 to that in 2012?
Your answer should be compact. 2.29. What is the ratio of the ODA received (in %) of Zambia in 2007 to that in 2012?
Your response must be concise. 2.07. What is the ratio of the ODA received (in %) in Bosnia and Herzegovina in 2007 to that in 2013?
Offer a very short reply. 1.24. What is the ratio of the ODA received (in %) in Colombia in 2007 to that in 2013?
Offer a very short reply. 1.55. What is the ratio of the ODA received (in %) in Sri Lanka in 2007 to that in 2013?
Your answer should be very brief. 2.97. What is the ratio of the ODA received (in %) of Zambia in 2007 to that in 2013?
Keep it short and to the point. 1.81. What is the ratio of the ODA received (in %) in Bosnia and Herzegovina in 2008 to that in 2009?
Provide a short and direct response. 1.04. What is the ratio of the ODA received (in %) in Colombia in 2008 to that in 2009?
Offer a very short reply. 0.88. What is the ratio of the ODA received (in %) in Sri Lanka in 2008 to that in 2009?
Keep it short and to the point. 1.09. What is the ratio of the ODA received (in %) of Zambia in 2008 to that in 2009?
Your answer should be compact. 0.8. What is the ratio of the ODA received (in %) of Bosnia and Herzegovina in 2008 to that in 2010?
Make the answer very short. 0.81. What is the ratio of the ODA received (in %) of Colombia in 2008 to that in 2010?
Provide a succinct answer. 1.27. What is the ratio of the ODA received (in %) of Sri Lanka in 2008 to that in 2010?
Your answer should be very brief. 1.78. What is the ratio of the ODA received (in %) in Zambia in 2008 to that in 2010?
Ensure brevity in your answer.  1.4. What is the ratio of the ODA received (in %) of Bosnia and Herzegovina in 2008 to that in 2011?
Keep it short and to the point. 0.71. What is the ratio of the ODA received (in %) in Colombia in 2008 to that in 2011?
Provide a succinct answer. 1.3. What is the ratio of the ODA received (in %) in Sri Lanka in 2008 to that in 2011?
Ensure brevity in your answer.  1.77. What is the ratio of the ODA received (in %) of Zambia in 2008 to that in 2011?
Provide a succinct answer. 1.47. What is the ratio of the ODA received (in %) of Bosnia and Herzegovina in 2008 to that in 2012?
Ensure brevity in your answer.  0.72. What is the ratio of the ODA received (in %) in Colombia in 2008 to that in 2012?
Keep it short and to the point. 1.92. What is the ratio of the ODA received (in %) of Sri Lanka in 2008 to that in 2012?
Give a very brief answer. 2.2. What is the ratio of the ODA received (in %) of Zambia in 2008 to that in 2012?
Your answer should be very brief. 1.74. What is the ratio of the ODA received (in %) in Bosnia and Herzegovina in 2008 to that in 2013?
Your answer should be very brief. 0.79. What is the ratio of the ODA received (in %) in Colombia in 2008 to that in 2013?
Make the answer very short. 1.78. What is the ratio of the ODA received (in %) in Sri Lanka in 2008 to that in 2013?
Ensure brevity in your answer.  2.85. What is the ratio of the ODA received (in %) in Zambia in 2008 to that in 2013?
Provide a succinct answer. 1.52. What is the ratio of the ODA received (in %) of Bosnia and Herzegovina in 2009 to that in 2010?
Offer a terse response. 0.77. What is the ratio of the ODA received (in %) of Colombia in 2009 to that in 2010?
Provide a succinct answer. 1.44. What is the ratio of the ODA received (in %) in Sri Lanka in 2009 to that in 2010?
Your response must be concise. 1.63. What is the ratio of the ODA received (in %) of Zambia in 2009 to that in 2010?
Your response must be concise. 1.76. What is the ratio of the ODA received (in %) in Bosnia and Herzegovina in 2009 to that in 2011?
Your answer should be very brief. 0.68. What is the ratio of the ODA received (in %) of Colombia in 2009 to that in 2011?
Your answer should be very brief. 1.48. What is the ratio of the ODA received (in %) of Sri Lanka in 2009 to that in 2011?
Your answer should be compact. 1.63. What is the ratio of the ODA received (in %) in Zambia in 2009 to that in 2011?
Your answer should be compact. 1.85. What is the ratio of the ODA received (in %) in Bosnia and Herzegovina in 2009 to that in 2012?
Provide a succinct answer. 0.69. What is the ratio of the ODA received (in %) in Colombia in 2009 to that in 2012?
Ensure brevity in your answer.  2.18. What is the ratio of the ODA received (in %) of Sri Lanka in 2009 to that in 2012?
Offer a very short reply. 2.02. What is the ratio of the ODA received (in %) in Zambia in 2009 to that in 2012?
Offer a terse response. 2.18. What is the ratio of the ODA received (in %) in Bosnia and Herzegovina in 2009 to that in 2013?
Give a very brief answer. 0.76. What is the ratio of the ODA received (in %) in Colombia in 2009 to that in 2013?
Make the answer very short. 2.02. What is the ratio of the ODA received (in %) of Sri Lanka in 2009 to that in 2013?
Make the answer very short. 2.61. What is the ratio of the ODA received (in %) of Zambia in 2009 to that in 2013?
Ensure brevity in your answer.  1.91. What is the ratio of the ODA received (in %) of Bosnia and Herzegovina in 2010 to that in 2011?
Your answer should be very brief. 0.88. What is the ratio of the ODA received (in %) of Colombia in 2010 to that in 2011?
Give a very brief answer. 1.03. What is the ratio of the ODA received (in %) of Zambia in 2010 to that in 2011?
Ensure brevity in your answer.  1.06. What is the ratio of the ODA received (in %) of Bosnia and Herzegovina in 2010 to that in 2012?
Your answer should be very brief. 0.89. What is the ratio of the ODA received (in %) of Colombia in 2010 to that in 2012?
Offer a very short reply. 1.52. What is the ratio of the ODA received (in %) of Sri Lanka in 2010 to that in 2012?
Provide a short and direct response. 1.23. What is the ratio of the ODA received (in %) in Zambia in 2010 to that in 2012?
Provide a succinct answer. 1.24. What is the ratio of the ODA received (in %) of Bosnia and Herzegovina in 2010 to that in 2013?
Ensure brevity in your answer.  0.98. What is the ratio of the ODA received (in %) of Colombia in 2010 to that in 2013?
Keep it short and to the point. 1.4. What is the ratio of the ODA received (in %) in Sri Lanka in 2010 to that in 2013?
Provide a short and direct response. 1.6. What is the ratio of the ODA received (in %) in Zambia in 2010 to that in 2013?
Provide a short and direct response. 1.09. What is the ratio of the ODA received (in %) in Bosnia and Herzegovina in 2011 to that in 2012?
Offer a very short reply. 1.01. What is the ratio of the ODA received (in %) in Colombia in 2011 to that in 2012?
Your response must be concise. 1.48. What is the ratio of the ODA received (in %) in Sri Lanka in 2011 to that in 2012?
Make the answer very short. 1.24. What is the ratio of the ODA received (in %) in Zambia in 2011 to that in 2012?
Give a very brief answer. 1.18. What is the ratio of the ODA received (in %) of Bosnia and Herzegovina in 2011 to that in 2013?
Offer a terse response. 1.11. What is the ratio of the ODA received (in %) of Colombia in 2011 to that in 2013?
Give a very brief answer. 1.37. What is the ratio of the ODA received (in %) in Sri Lanka in 2011 to that in 2013?
Give a very brief answer. 1.61. What is the ratio of the ODA received (in %) in Zambia in 2011 to that in 2013?
Ensure brevity in your answer.  1.03. What is the ratio of the ODA received (in %) in Bosnia and Herzegovina in 2012 to that in 2013?
Make the answer very short. 1.1. What is the ratio of the ODA received (in %) of Colombia in 2012 to that in 2013?
Your answer should be compact. 0.93. What is the ratio of the ODA received (in %) in Sri Lanka in 2012 to that in 2013?
Offer a terse response. 1.3. What is the ratio of the ODA received (in %) of Zambia in 2012 to that in 2013?
Your response must be concise. 0.87. What is the difference between the highest and the second highest ODA received (in %) of Bosnia and Herzegovina?
Your answer should be very brief. 0.38. What is the difference between the highest and the second highest ODA received (in %) in Colombia?
Provide a succinct answer. 0.06. What is the difference between the highest and the second highest ODA received (in %) in Sri Lanka?
Offer a terse response. 0.08. What is the difference between the highest and the second highest ODA received (in %) of Zambia?
Provide a short and direct response. 0.44. What is the difference between the highest and the lowest ODA received (in %) of Bosnia and Herzegovina?
Your answer should be very brief. 1.46. What is the difference between the highest and the lowest ODA received (in %) in Colombia?
Your answer should be compact. 0.25. What is the difference between the highest and the lowest ODA received (in %) in Sri Lanka?
Your answer should be very brief. 1.27. What is the difference between the highest and the lowest ODA received (in %) in Zambia?
Provide a short and direct response. 4.61. 